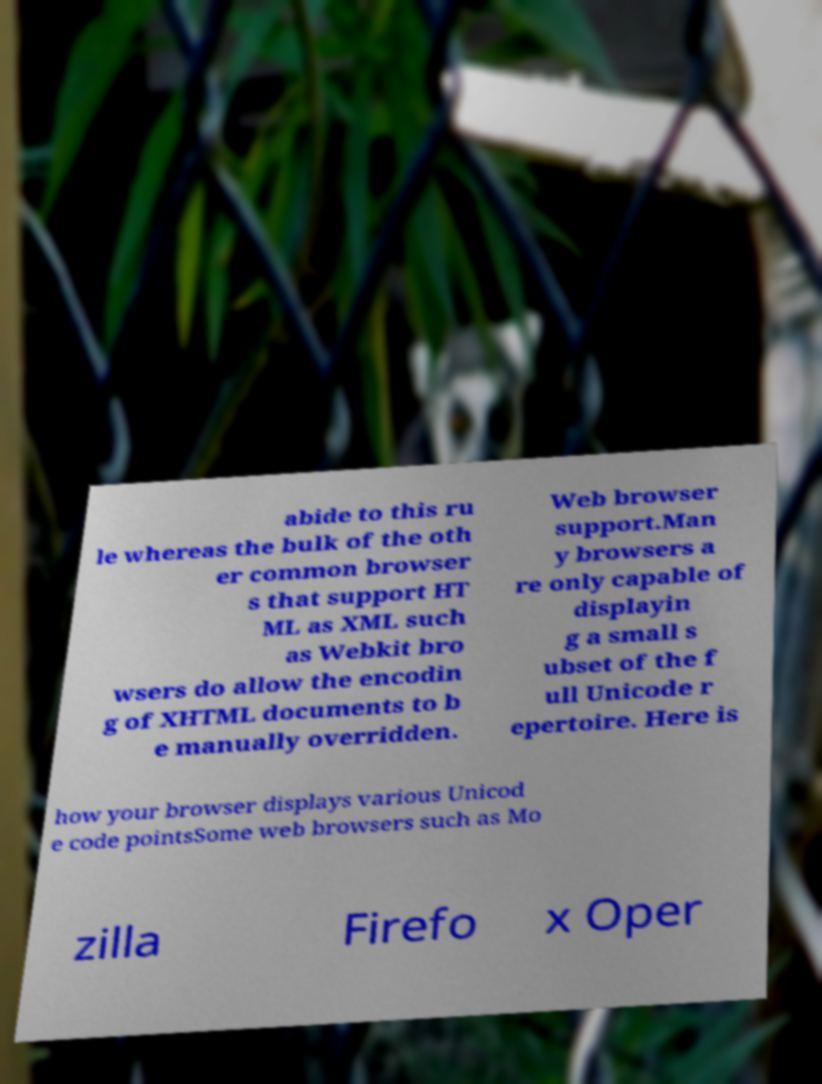Please read and relay the text visible in this image. What does it say? abide to this ru le whereas the bulk of the oth er common browser s that support HT ML as XML such as Webkit bro wsers do allow the encodin g of XHTML documents to b e manually overridden. Web browser support.Man y browsers a re only capable of displayin g a small s ubset of the f ull Unicode r epertoire. Here is how your browser displays various Unicod e code pointsSome web browsers such as Mo zilla Firefo x Oper 